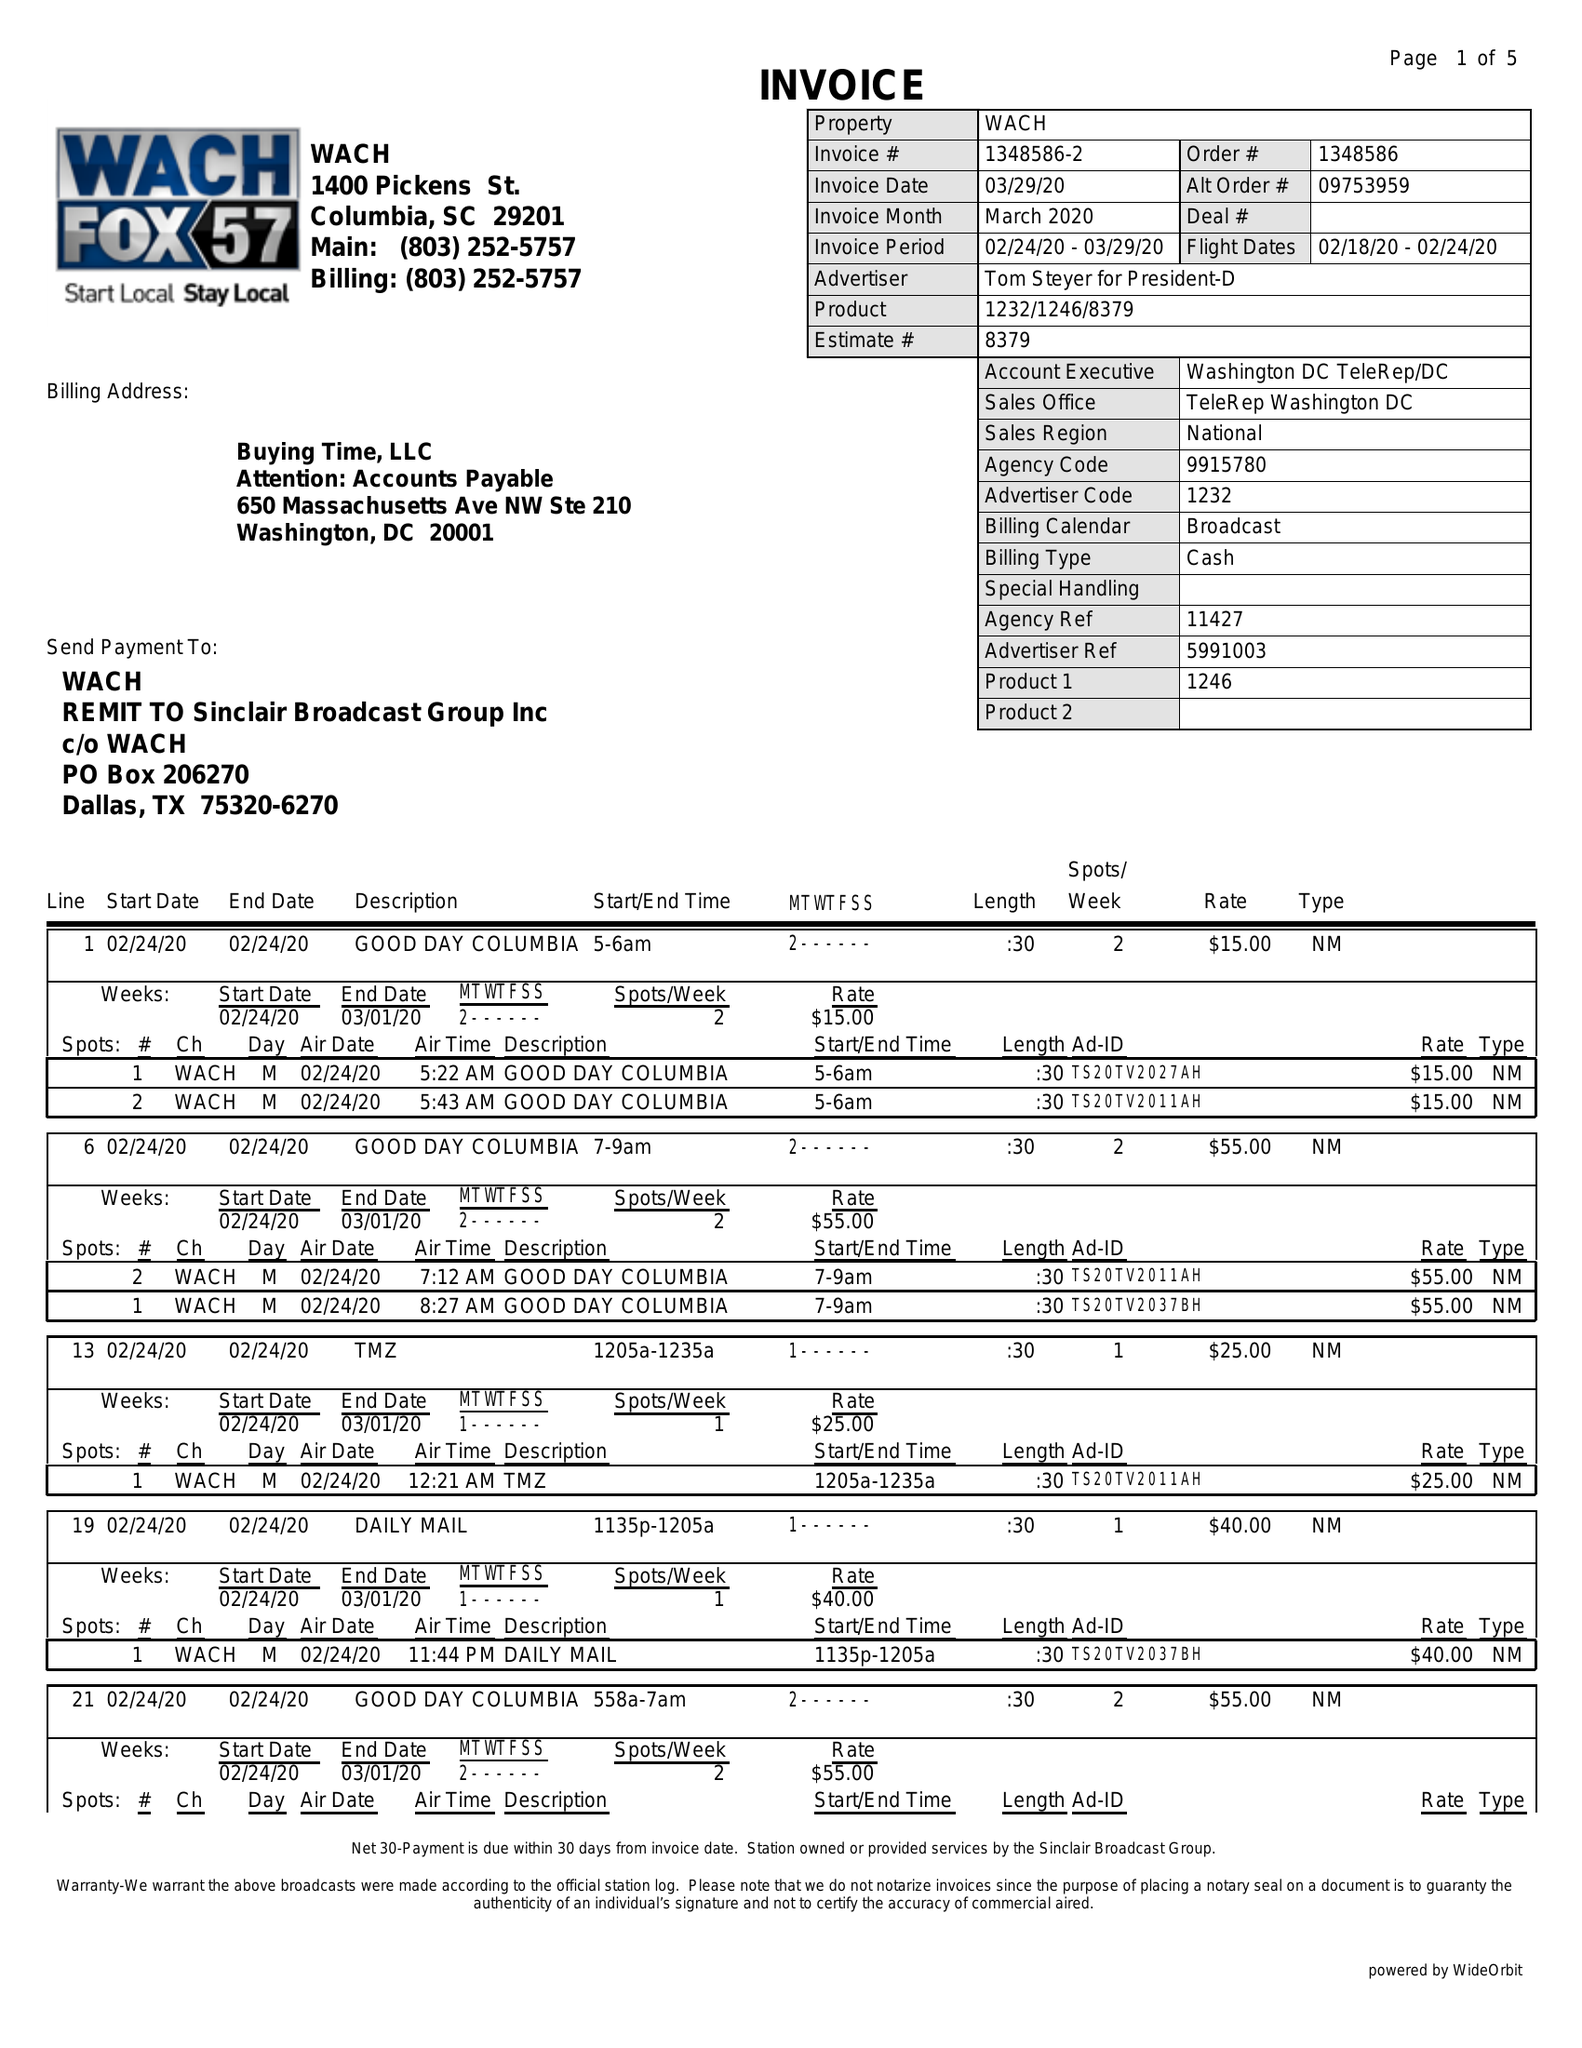What is the value for the gross_amount?
Answer the question using a single word or phrase. 3480.00 